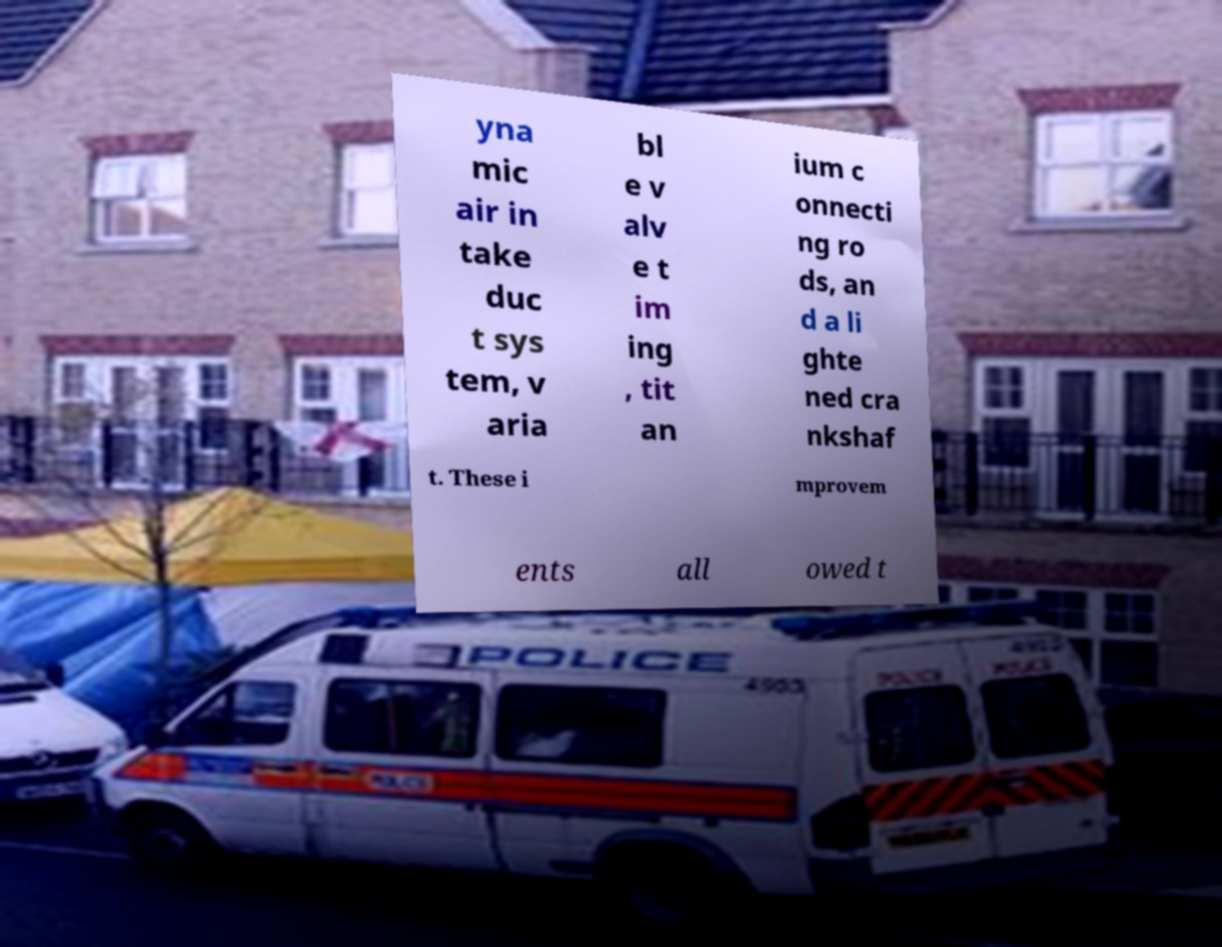I need the written content from this picture converted into text. Can you do that? yna mic air in take duc t sys tem, v aria bl e v alv e t im ing , tit an ium c onnecti ng ro ds, an d a li ghte ned cra nkshaf t. These i mprovem ents all owed t 